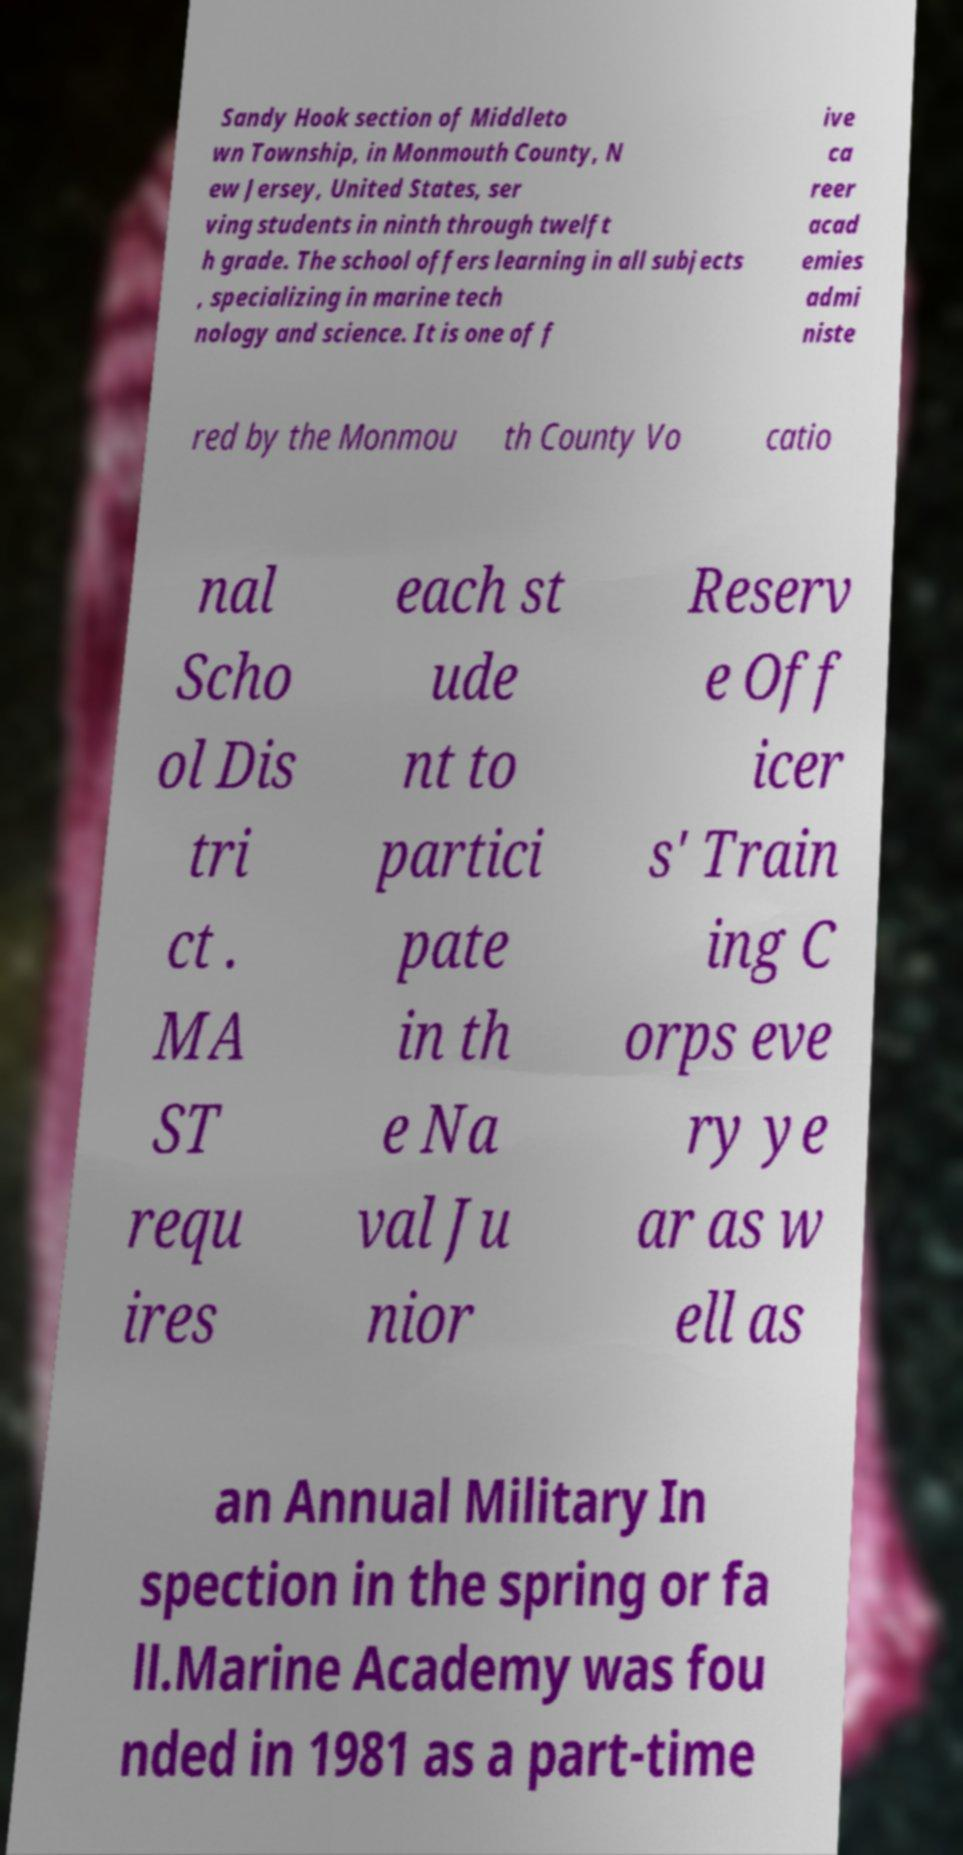Could you assist in decoding the text presented in this image and type it out clearly? Sandy Hook section of Middleto wn Township, in Monmouth County, N ew Jersey, United States, ser ving students in ninth through twelft h grade. The school offers learning in all subjects , specializing in marine tech nology and science. It is one of f ive ca reer acad emies admi niste red by the Monmou th County Vo catio nal Scho ol Dis tri ct . MA ST requ ires each st ude nt to partici pate in th e Na val Ju nior Reserv e Off icer s' Train ing C orps eve ry ye ar as w ell as an Annual Military In spection in the spring or fa ll.Marine Academy was fou nded in 1981 as a part-time 